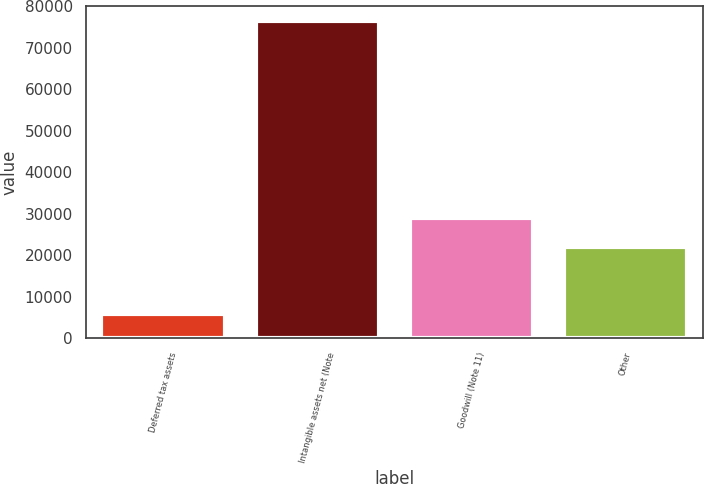<chart> <loc_0><loc_0><loc_500><loc_500><bar_chart><fcel>Deferred tax assets<fcel>Intangible assets net (Note<fcel>Goodwill (Note 11)<fcel>Other<nl><fcel>5914<fcel>76295<fcel>28891.1<fcel>21853<nl></chart> 